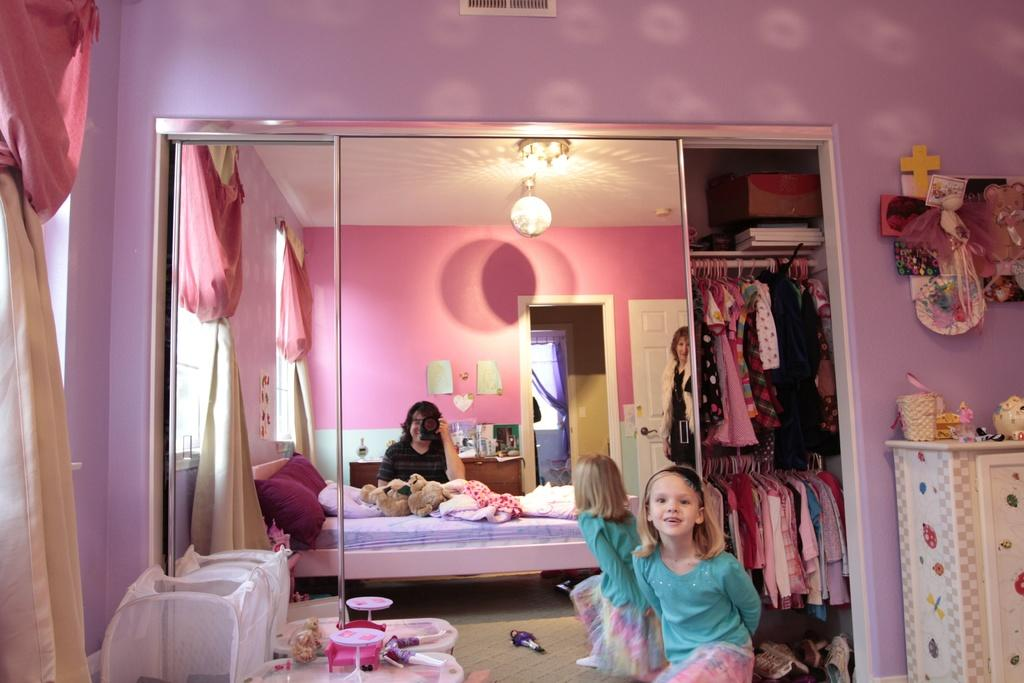How many people are in the image? There are two persons in the image. What is one of the persons doing? One of the persons is holding a camera. What can be seen in the background of the image? There is a mirror, a cupboard, and a bed in the image. What is on the bed? There is a pillow and a blanket on the bed. What is on the table? There are items on the table. What type of hat is the child wearing in the image? There is no hat present in the image; the child is not wearing one. What word is written on the pillow in the image? There is no word written on the pillow in the image; it is just a regular pillow. 